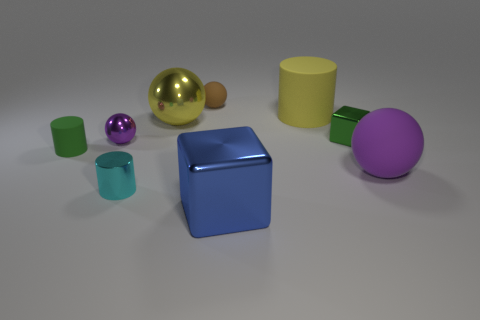What is the material of the small cyan cylinder?
Ensure brevity in your answer.  Metal. Are the ball that is to the right of the large yellow rubber object and the small brown thing made of the same material?
Your answer should be compact. Yes. Are there fewer small brown matte spheres that are right of the large matte ball than small matte cylinders?
Your answer should be compact. Yes. What color is the cube that is the same size as the purple rubber sphere?
Your answer should be compact. Blue. What number of green metal things are the same shape as the blue object?
Provide a succinct answer. 1. The tiny cylinder in front of the green rubber cylinder is what color?
Your response must be concise. Cyan. What number of rubber things are either small blue spheres or large blue things?
Give a very brief answer. 0. There is a thing that is the same color as the small cube; what shape is it?
Your answer should be compact. Cylinder. What number of purple rubber objects have the same size as the yellow cylinder?
Keep it short and to the point. 1. There is a thing that is left of the brown sphere and behind the green metal block; what color is it?
Give a very brief answer. Yellow. 